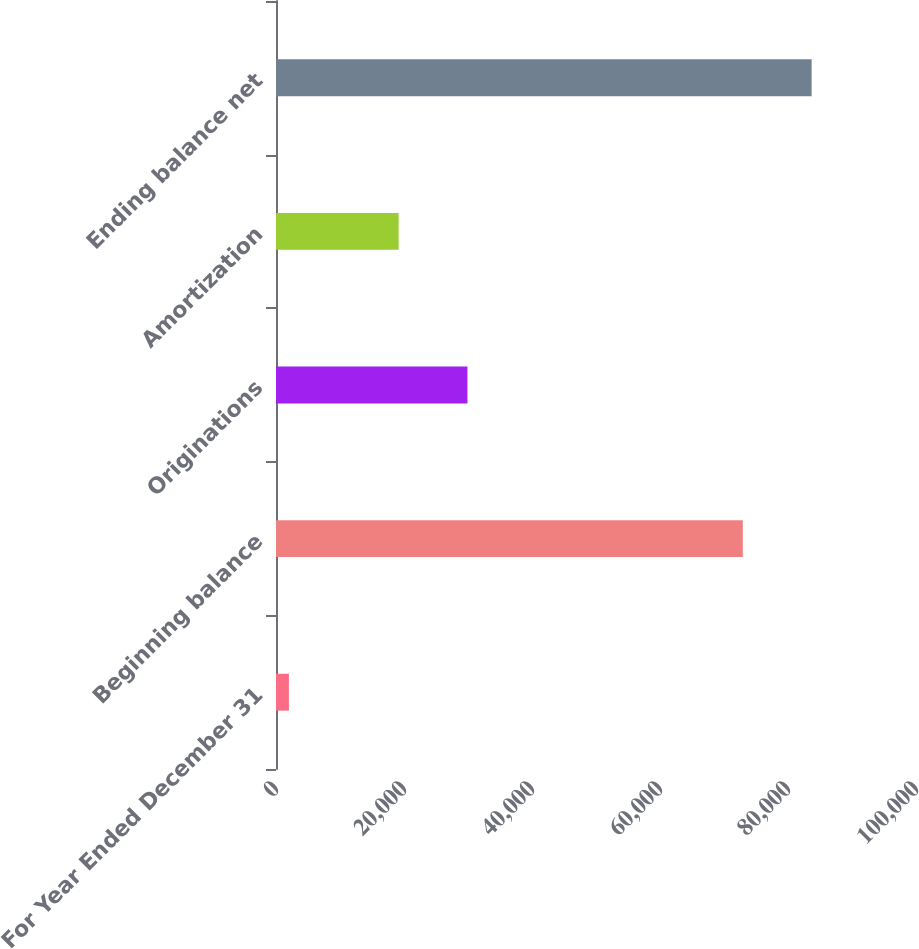<chart> <loc_0><loc_0><loc_500><loc_500><bar_chart><fcel>For Year Ended December 31<fcel>Beginning balance<fcel>Originations<fcel>Amortization<fcel>Ending balance net<nl><fcel>2015<fcel>72939<fcel>29914<fcel>19161<fcel>83692<nl></chart> 